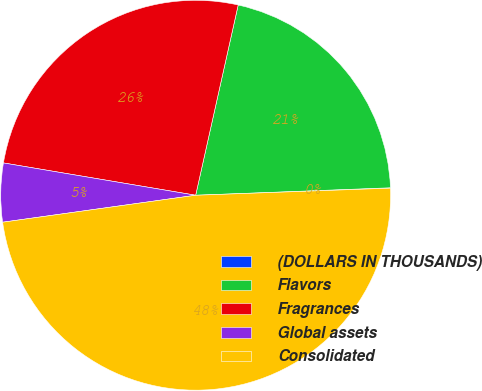<chart> <loc_0><loc_0><loc_500><loc_500><pie_chart><fcel>(DOLLARS IN THOUSANDS)<fcel>Flavors<fcel>Fragrances<fcel>Global assets<fcel>Consolidated<nl><fcel>0.03%<fcel>20.89%<fcel>25.85%<fcel>4.86%<fcel>48.37%<nl></chart> 